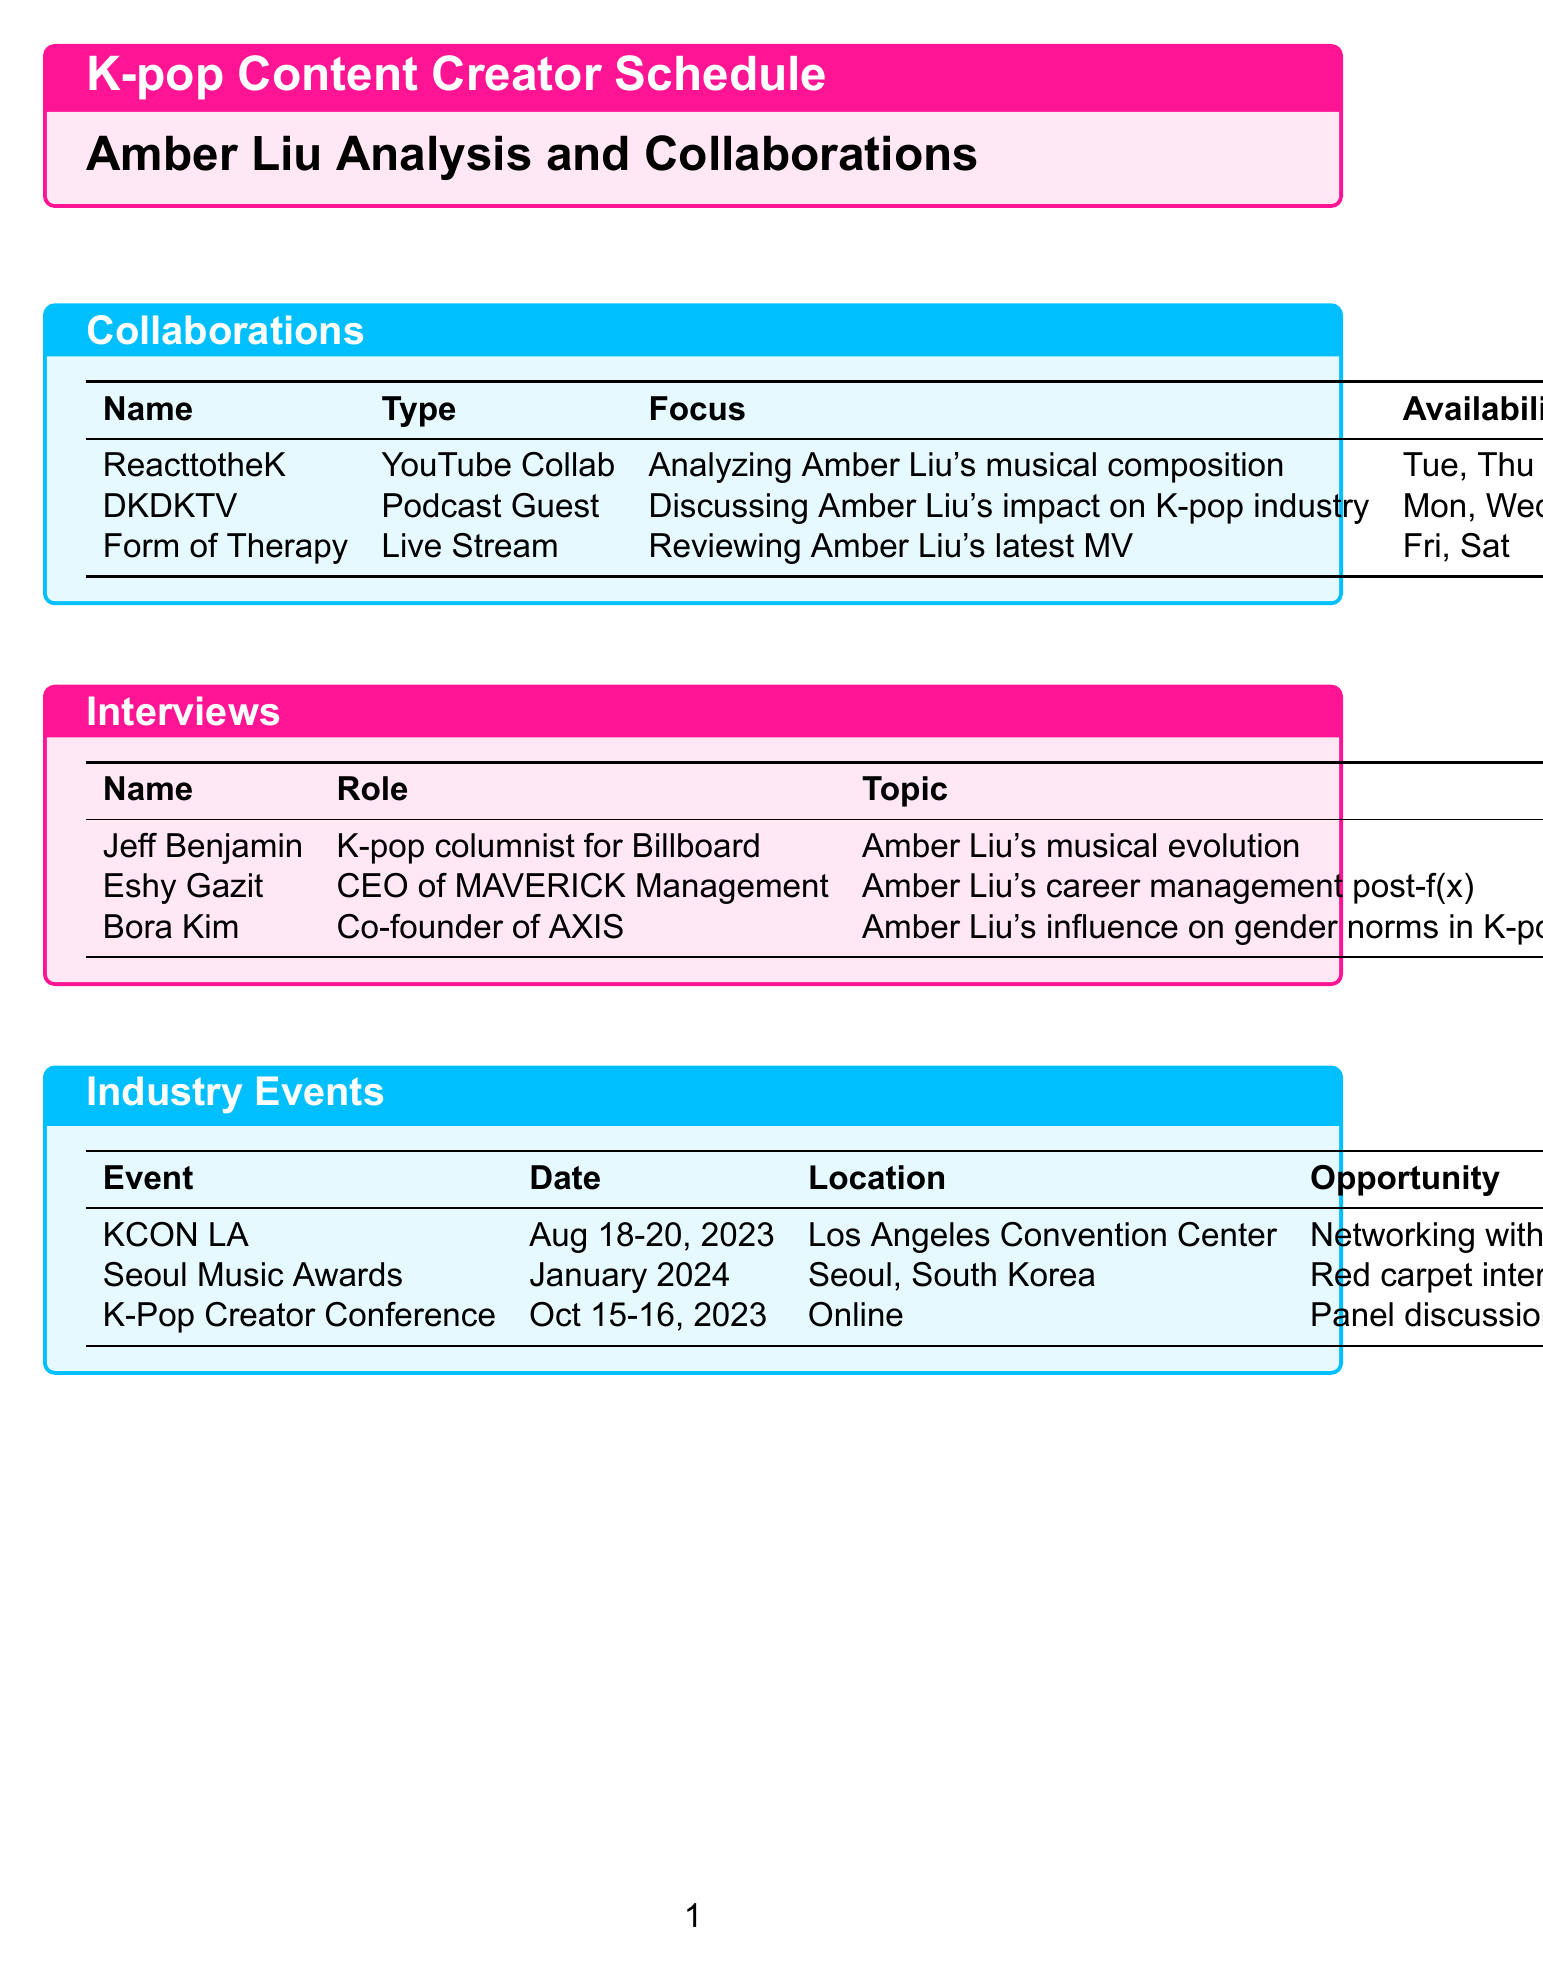What is the name of the YouTube collaboration? The document lists ReacttotheK as the YouTube collaboration for analyzing Amber Liu's musical composition.
Answer: ReacttotheK Which platform is used for interviews with Jeff Benjamin? The document specifies that the interview with Jeff Benjamin takes place on Skype.
Answer: Skype When is KCON LA scheduled to occur? According to the document, KCON LA is scheduled for August 18-20, 2023.
Answer: August 18-20, 2023 What is the focus of the live stream collaboration? The document indicates that the focus of the live stream is reviewing Amber Liu's latest MV.
Answer: Reviewing Amber Liu's latest MV How many days is the K-Pop Creator Conference? The document states that the K-Pop Creator Conference lasts for two days, October 15-16, 2023.
Answer: Two days Which role does Eshy Gazit hold? The document lists Eshy Gazit as the CEO of MAVERICK Management.
Answer: CEO of MAVERICK Management On what day can you schedule an interview with Bora Kim? The document shows that an interview with Bora Kim can be scheduled on Wednesdays or Fridays.
Answer: Wednesdays, Fridays What is the topic of discussion for DKDKTV? The document mentions that DKDKTV discusses Amber Liu's impact on the K-pop industry.
Answer: Amber Liu's impact on K-pop industry 